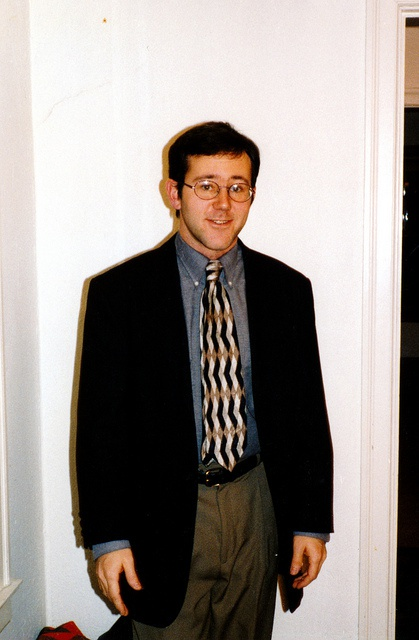Describe the objects in this image and their specific colors. I can see people in lightgray, black, maroon, gray, and brown tones and tie in lightgray, black, gray, and darkgray tones in this image. 